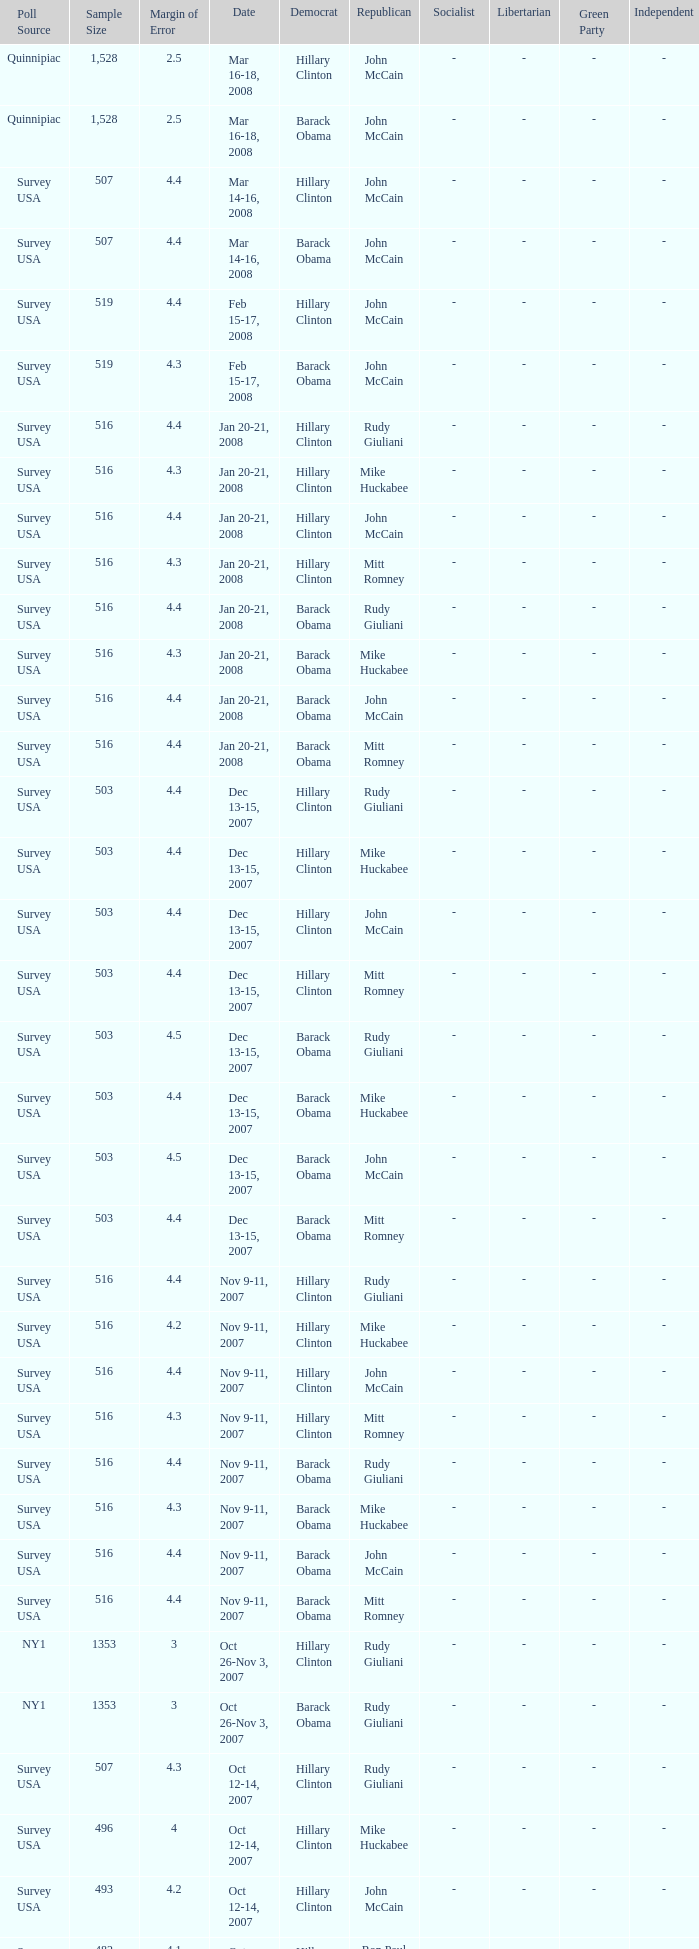Which Democrat was selected in the poll with a sample size smaller than 516 where the Republican chosen was Ron Paul? Hillary Clinton. 